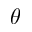Convert formula to latex. <formula><loc_0><loc_0><loc_500><loc_500>\theta</formula> 